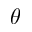Convert formula to latex. <formula><loc_0><loc_0><loc_500><loc_500>\theta</formula> 